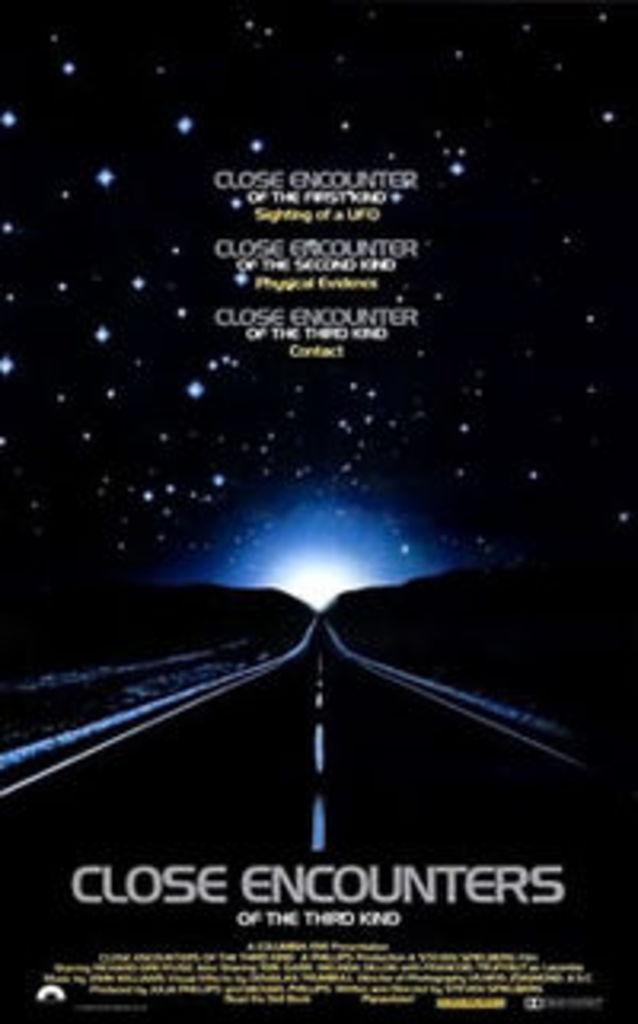<image>
Write a terse but informative summary of the picture. The movie poster for "Close Encounters Of The Third Kind". 